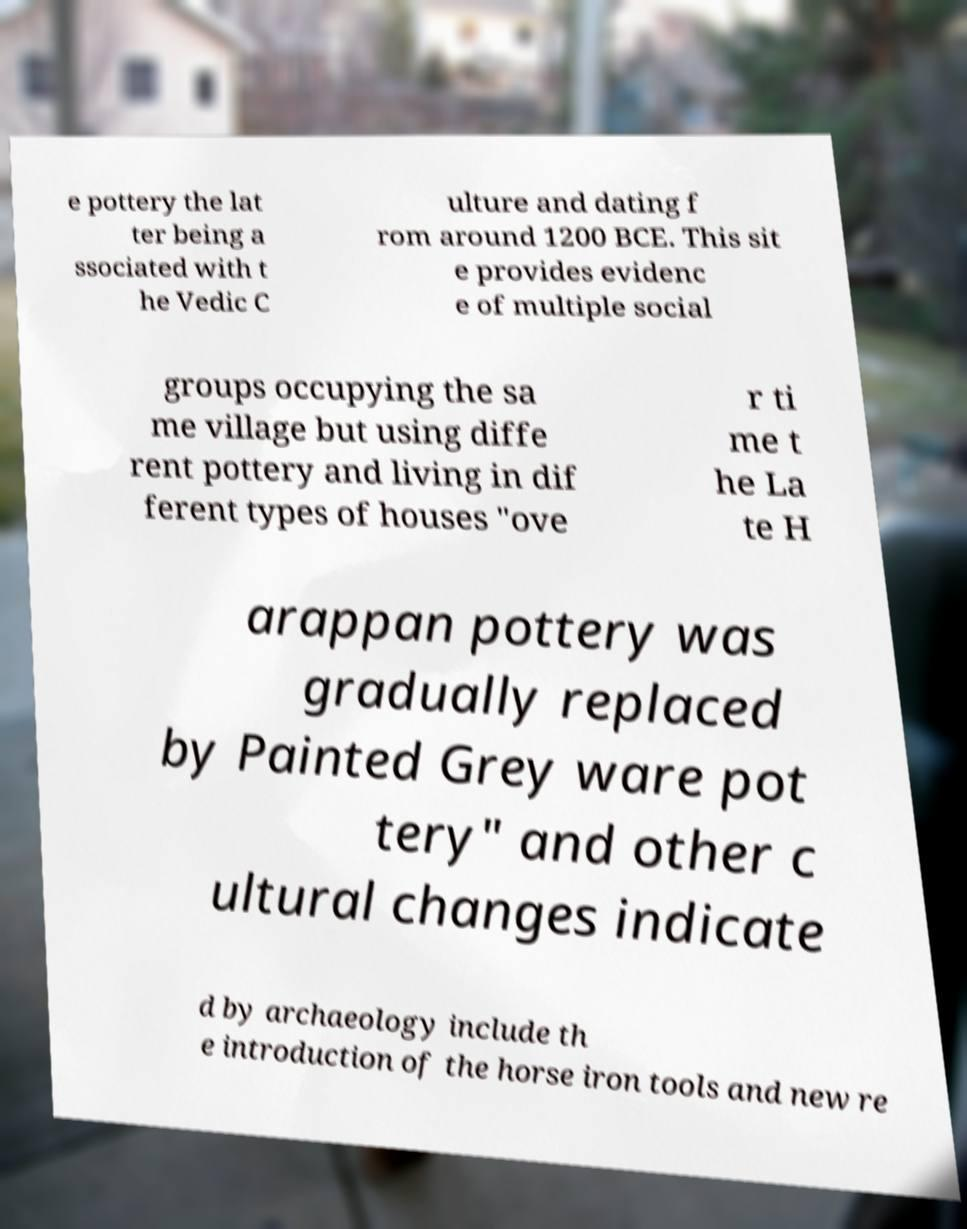Can you accurately transcribe the text from the provided image for me? e pottery the lat ter being a ssociated with t he Vedic C ulture and dating f rom around 1200 BCE. This sit e provides evidenc e of multiple social groups occupying the sa me village but using diffe rent pottery and living in dif ferent types of houses "ove r ti me t he La te H arappan pottery was gradually replaced by Painted Grey ware pot tery" and other c ultural changes indicate d by archaeology include th e introduction of the horse iron tools and new re 